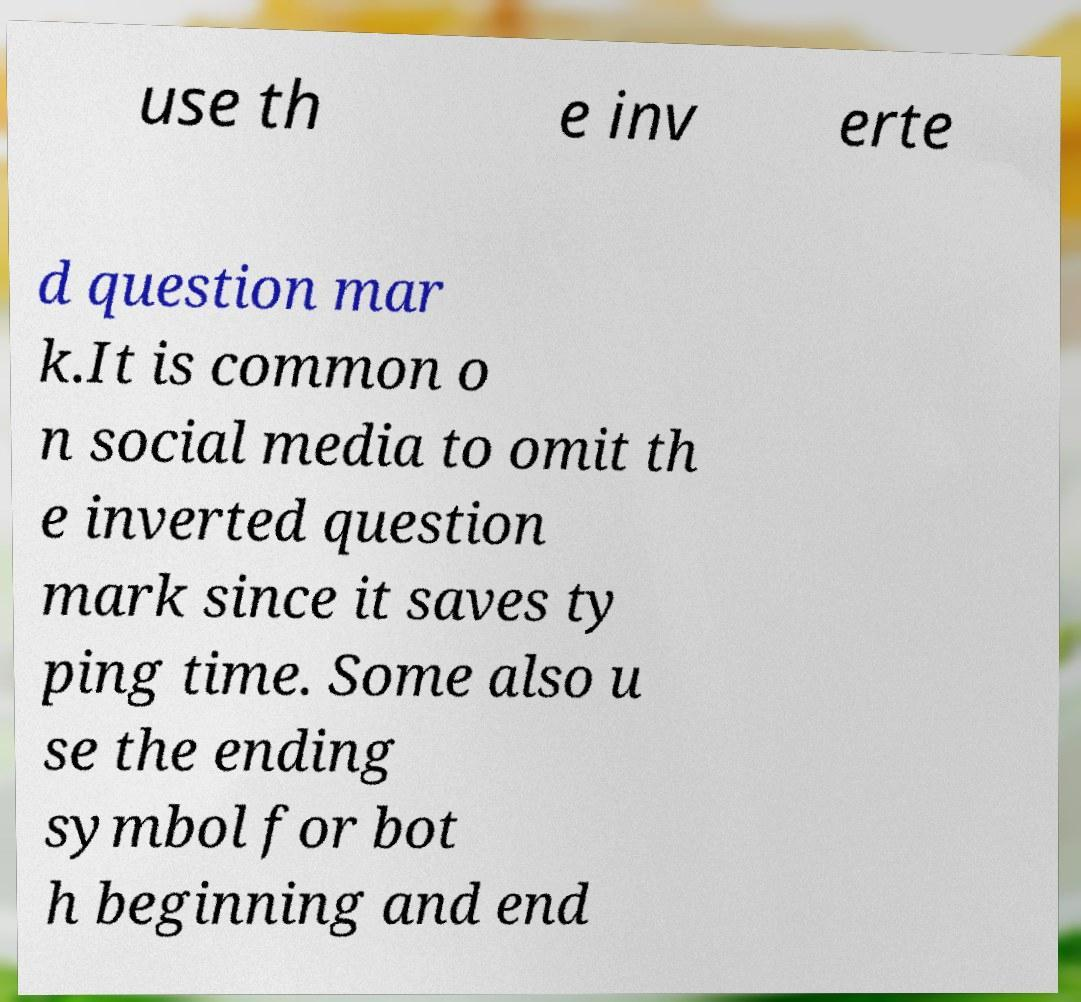I need the written content from this picture converted into text. Can you do that? use th e inv erte d question mar k.It is common o n social media to omit th e inverted question mark since it saves ty ping time. Some also u se the ending symbol for bot h beginning and end 